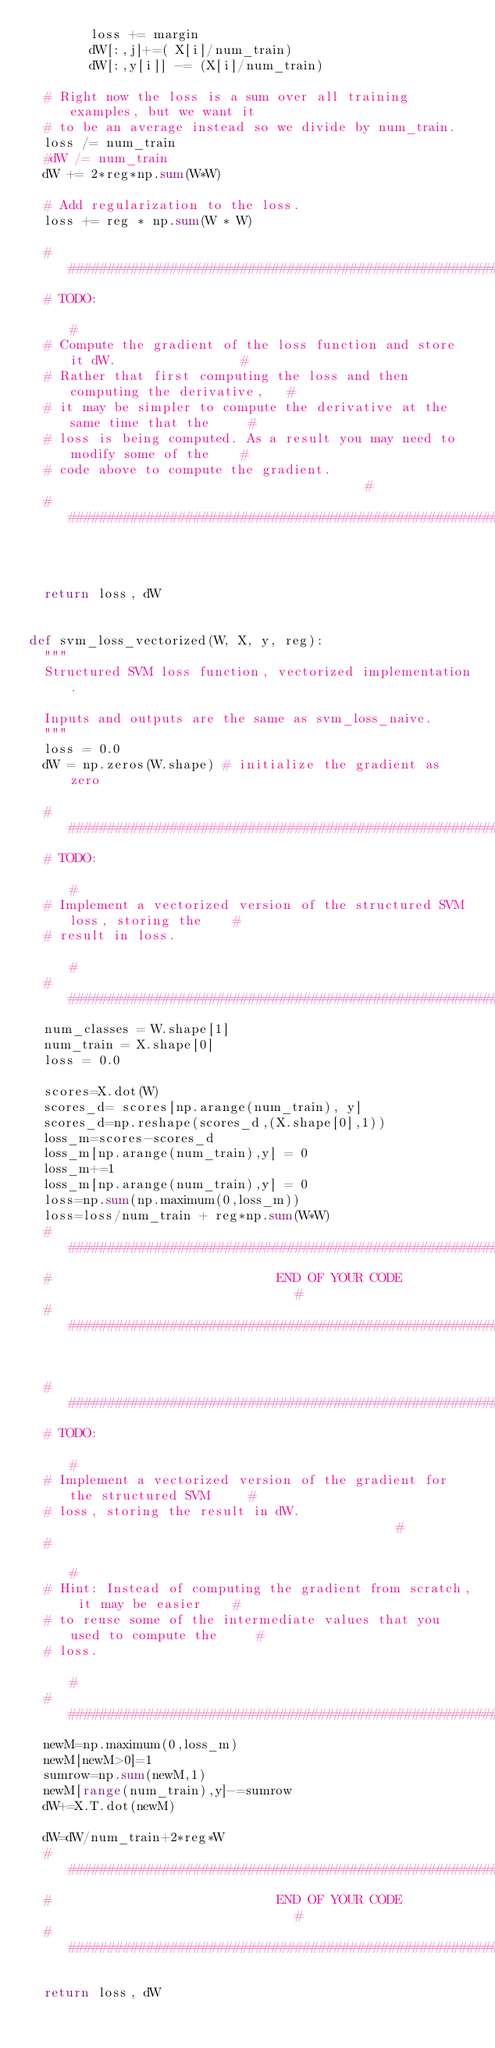<code> <loc_0><loc_0><loc_500><loc_500><_Python_>        loss += margin
        dW[:,j]+=( X[i]/num_train)
        dW[:,y[i]] -= (X[i]/num_train)

  # Right now the loss is a sum over all training examples, but we want it
  # to be an average instead so we divide by num_train.
  loss /= num_train
  #dW /= num_train
  dW += 2*reg*np.sum(W*W)

  # Add regularization to the loss.
  loss += reg * np.sum(W * W)

  #############################################################################
  # TODO:                                                                     #
  # Compute the gradient of the loss function and store it dW.                #
  # Rather that first computing the loss and then computing the derivative,   #
  # it may be simpler to compute the derivative at the same time that the     #
  # loss is being computed. As a result you may need to modify some of the    #
  # code above to compute the gradient.                                       #
  #############################################################################



  return loss, dW


def svm_loss_vectorized(W, X, y, reg):
  """
  Structured SVM loss function, vectorized implementation.

  Inputs and outputs are the same as svm_loss_naive.
  """
  loss = 0.0
  dW = np.zeros(W.shape) # initialize the gradient as zero

  #############################################################################
  # TODO:                                                                     #
  # Implement a vectorized version of the structured SVM loss, storing the    #
  # result in loss.                                                           #
  #############################################################################
  num_classes = W.shape[1]
  num_train = X.shape[0]
  loss = 0.0

  scores=X.dot(W)
  scores_d= scores[np.arange(num_train), y]
  scores_d=np.reshape(scores_d,(X.shape[0],1))
  loss_m=scores-scores_d
  loss_m[np.arange(num_train),y] = 0
  loss_m+=1
  loss_m[np.arange(num_train),y] = 0
  loss=np.sum(np.maximum(0,loss_m))
  loss=loss/num_train + reg*np.sum(W*W)
  #############################################################################
  #                             END OF YOUR CODE                              #
  #############################################################################


  #############################################################################
  # TODO:                                                                     #
  # Implement a vectorized version of the gradient for the structured SVM     #
  # loss, storing the result in dW.                                           #
  #                                                                           #
  # Hint: Instead of computing the gradient from scratch, it may be easier    #
  # to reuse some of the intermediate values that you used to compute the     #
  # loss.                                                                     #
  #############################################################################
  newM=np.maximum(0,loss_m)
  newM[newM>0]=1
  sumrow=np.sum(newM,1)
  newM[range(num_train),y]-=sumrow
  dW+=X.T.dot(newM)

  dW=dW/num_train+2*reg*W
  #############################################################################
  #                             END OF YOUR CODE                              #
  #############################################################################

  return loss, dW
</code> 